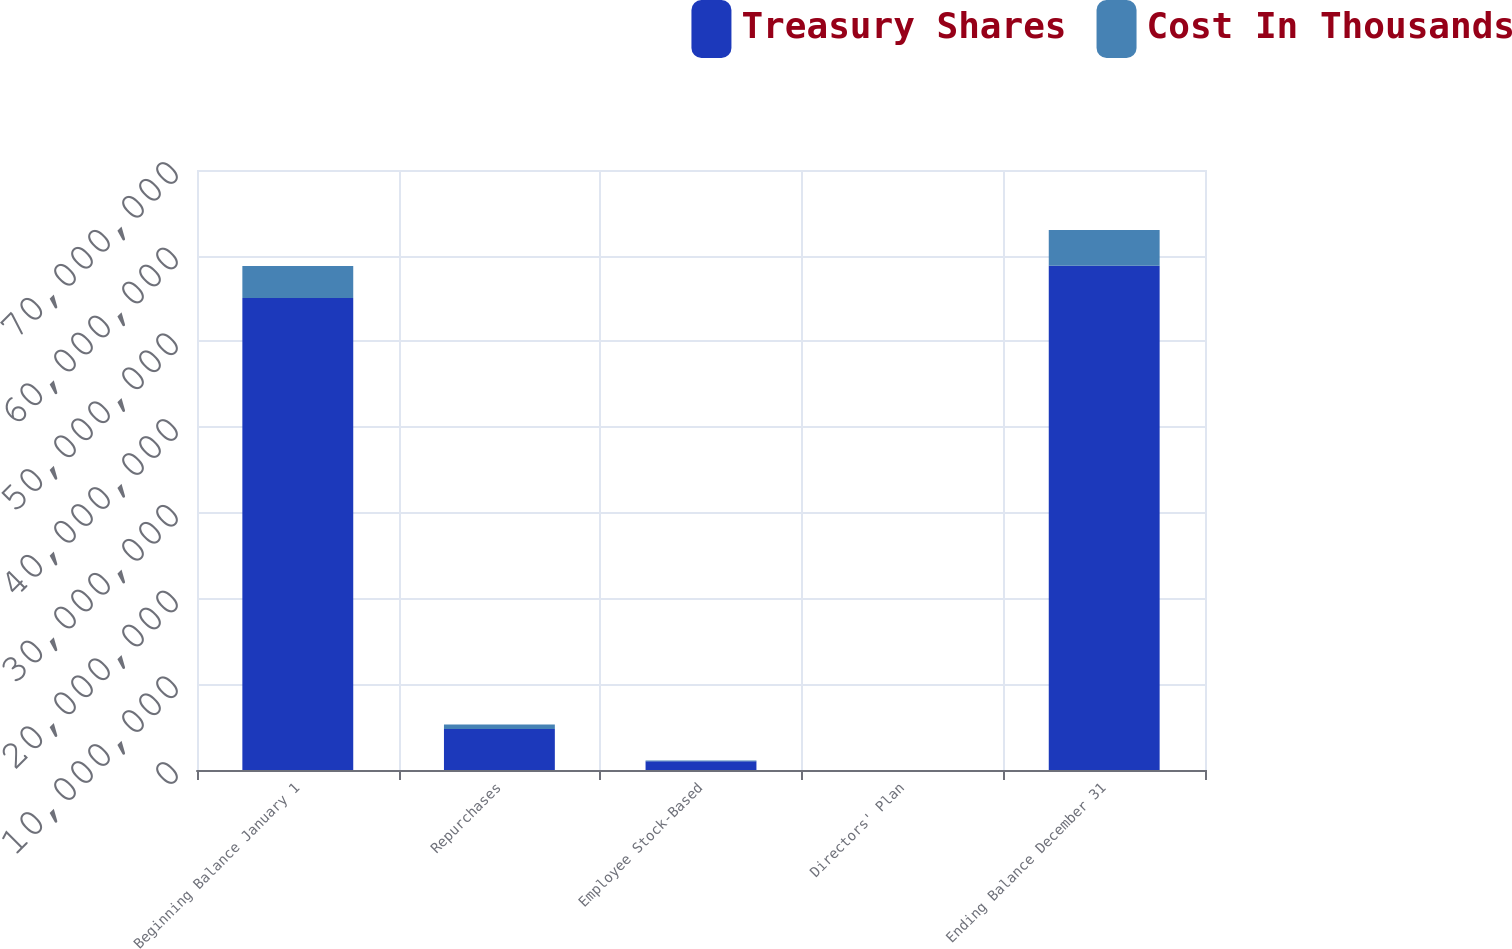<chart> <loc_0><loc_0><loc_500><loc_500><stacked_bar_chart><ecel><fcel>Beginning Balance January 1<fcel>Repurchases<fcel>Employee Stock-Based<fcel>Directors' Plan<fcel>Ending Balance December 31<nl><fcel>Treasury Shares<fcel>5.50538e+07<fcel>4.7923e+06<fcel>1.02541e+06<fcel>5220<fcel>5.88155e+07<nl><fcel>Cost In Thousands<fcel>3.73486e+06<fcel>512351<fcel>71636<fcel>366<fcel>4.17521e+06<nl></chart> 